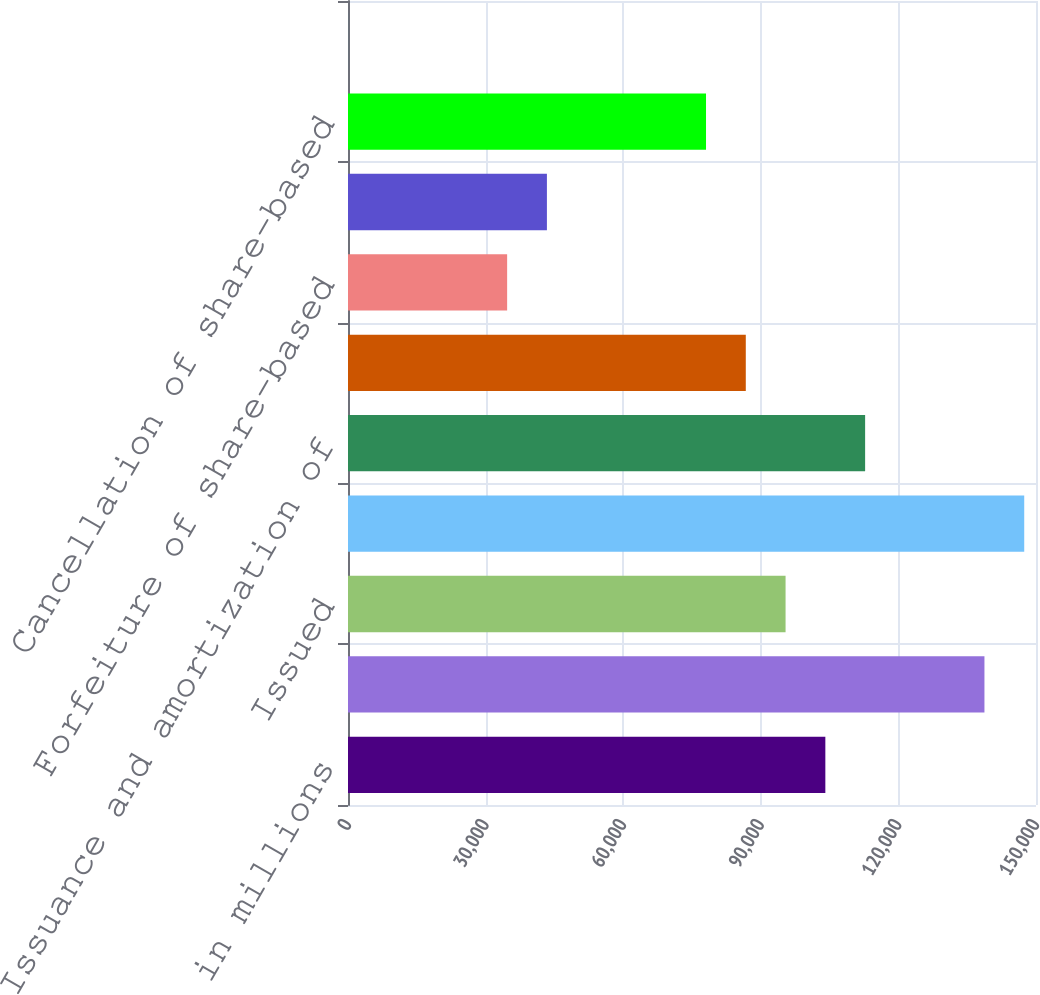Convert chart to OTSL. <chart><loc_0><loc_0><loc_500><loc_500><bar_chart><fcel>in millions<fcel>Beginning balance<fcel>Issued<fcel>Ending balance<fcel>Issuance and amortization of<fcel>Delivery of common stock<fcel>Forfeiture of share-based<fcel>Exercise of share-based awards<fcel>Cancellation of share-based<fcel>Preferred stock issuance costs<nl><fcel>104072<fcel>138761<fcel>95400.1<fcel>147433<fcel>112744<fcel>86728<fcel>34695.4<fcel>43367.5<fcel>78055.9<fcel>7<nl></chart> 